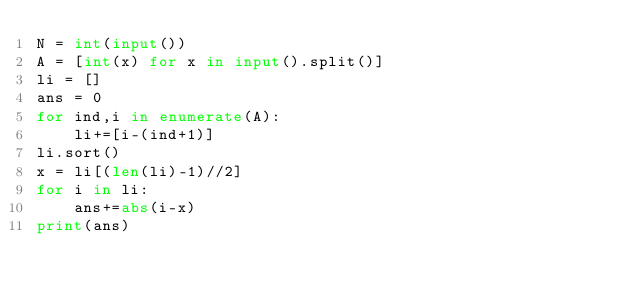<code> <loc_0><loc_0><loc_500><loc_500><_Python_>N = int(input())
A = [int(x) for x in input().split()]
li = []
ans = 0
for ind,i in enumerate(A):
    li+=[i-(ind+1)]
li.sort()
x = li[(len(li)-1)//2]
for i in li:
    ans+=abs(i-x)
print(ans)
</code> 